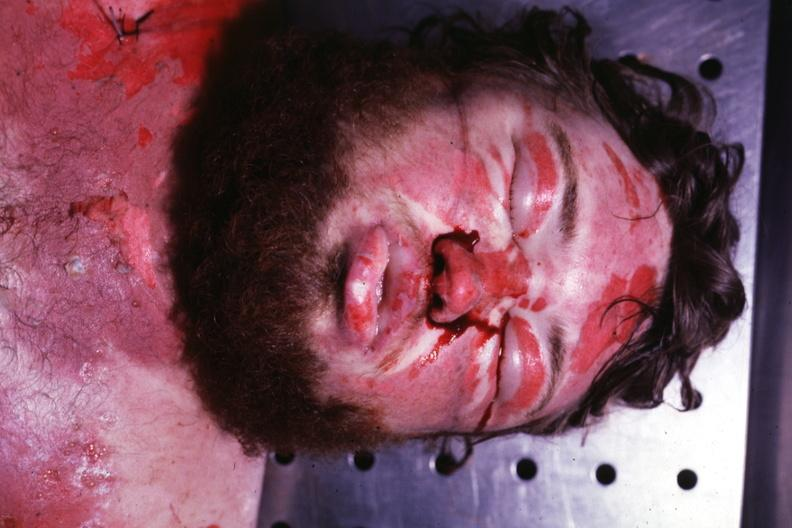does this image show severe body burns 24 hours anasarca?
Answer the question using a single word or phrase. Yes 